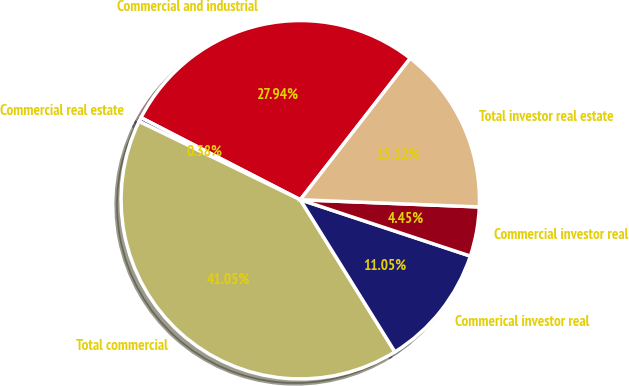<chart> <loc_0><loc_0><loc_500><loc_500><pie_chart><fcel>Commercial and industrial<fcel>Commercial real estate<fcel>Total commercial<fcel>Commerical investor real<fcel>Commercial investor real<fcel>Total investor real estate<nl><fcel>27.94%<fcel>0.38%<fcel>41.05%<fcel>11.05%<fcel>4.45%<fcel>15.12%<nl></chart> 